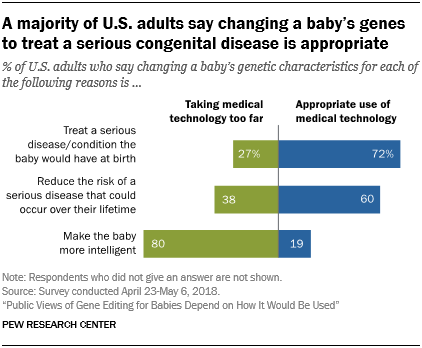Point out several critical features in this image. The longest bar color of the first graph bar is blue. The sum of the last two green bar values is 118. 